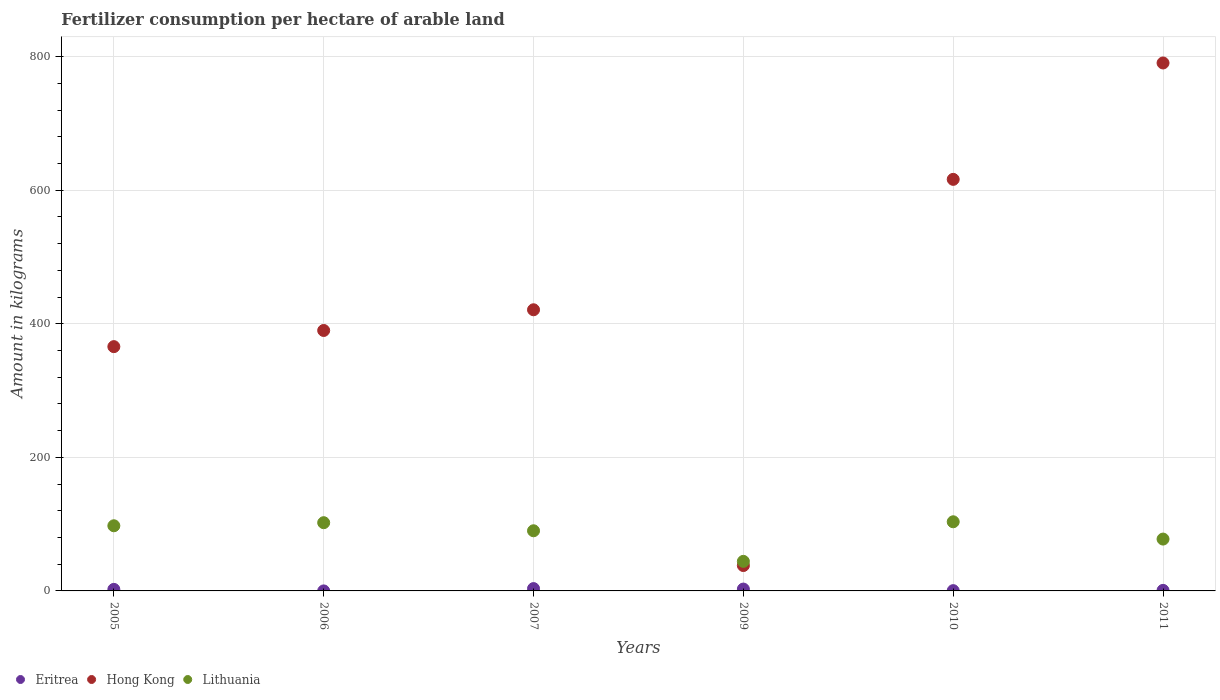How many different coloured dotlines are there?
Provide a short and direct response. 3. What is the amount of fertilizer consumption in Hong Kong in 2011?
Provide a succinct answer. 790.57. Across all years, what is the maximum amount of fertilizer consumption in Hong Kong?
Your answer should be compact. 790.57. Across all years, what is the minimum amount of fertilizer consumption in Eritrea?
Provide a short and direct response. 0.02. In which year was the amount of fertilizer consumption in Hong Kong maximum?
Offer a terse response. 2011. In which year was the amount of fertilizer consumption in Lithuania minimum?
Your answer should be very brief. 2009. What is the total amount of fertilizer consumption in Lithuania in the graph?
Keep it short and to the point. 515.22. What is the difference between the amount of fertilizer consumption in Lithuania in 2007 and that in 2010?
Offer a terse response. -13.47. What is the difference between the amount of fertilizer consumption in Lithuania in 2011 and the amount of fertilizer consumption in Eritrea in 2009?
Your response must be concise. 74.85. What is the average amount of fertilizer consumption in Hong Kong per year?
Your answer should be very brief. 436.94. In the year 2006, what is the difference between the amount of fertilizer consumption in Hong Kong and amount of fertilizer consumption in Lithuania?
Offer a terse response. 287.83. What is the ratio of the amount of fertilizer consumption in Lithuania in 2007 to that in 2009?
Your answer should be compact. 2.04. Is the amount of fertilizer consumption in Lithuania in 2009 less than that in 2011?
Provide a succinct answer. Yes. What is the difference between the highest and the second highest amount of fertilizer consumption in Hong Kong?
Your answer should be very brief. 174.29. What is the difference between the highest and the lowest amount of fertilizer consumption in Eritrea?
Your response must be concise. 3.47. Is the sum of the amount of fertilizer consumption in Eritrea in 2005 and 2010 greater than the maximum amount of fertilizer consumption in Lithuania across all years?
Ensure brevity in your answer.  No. Is the amount of fertilizer consumption in Hong Kong strictly greater than the amount of fertilizer consumption in Eritrea over the years?
Ensure brevity in your answer.  Yes. What is the difference between two consecutive major ticks on the Y-axis?
Your answer should be compact. 200. Does the graph contain any zero values?
Provide a short and direct response. No. Where does the legend appear in the graph?
Offer a very short reply. Bottom left. What is the title of the graph?
Your response must be concise. Fertilizer consumption per hectare of arable land. Does "Romania" appear as one of the legend labels in the graph?
Provide a short and direct response. No. What is the label or title of the X-axis?
Your answer should be very brief. Years. What is the label or title of the Y-axis?
Your response must be concise. Amount in kilograms. What is the Amount in kilograms of Eritrea in 2005?
Offer a very short reply. 2.32. What is the Amount in kilograms in Hong Kong in 2005?
Offer a very short reply. 365.8. What is the Amount in kilograms of Lithuania in 2005?
Offer a very short reply. 97.56. What is the Amount in kilograms of Eritrea in 2006?
Offer a terse response. 0.02. What is the Amount in kilograms in Hong Kong in 2006?
Your answer should be compact. 390. What is the Amount in kilograms of Lithuania in 2006?
Provide a succinct answer. 102.17. What is the Amount in kilograms in Eritrea in 2007?
Your answer should be compact. 3.49. What is the Amount in kilograms of Hong Kong in 2007?
Make the answer very short. 421. What is the Amount in kilograms in Lithuania in 2007?
Offer a terse response. 90.07. What is the Amount in kilograms in Eritrea in 2009?
Provide a succinct answer. 2.78. What is the Amount in kilograms of Hong Kong in 2009?
Keep it short and to the point. 38. What is the Amount in kilograms of Lithuania in 2009?
Keep it short and to the point. 44.26. What is the Amount in kilograms in Eritrea in 2010?
Your response must be concise. 0.42. What is the Amount in kilograms of Hong Kong in 2010?
Provide a short and direct response. 616.29. What is the Amount in kilograms of Lithuania in 2010?
Make the answer very short. 103.53. What is the Amount in kilograms in Eritrea in 2011?
Keep it short and to the point. 0.82. What is the Amount in kilograms of Hong Kong in 2011?
Offer a very short reply. 790.57. What is the Amount in kilograms in Lithuania in 2011?
Your answer should be compact. 77.63. Across all years, what is the maximum Amount in kilograms in Eritrea?
Your answer should be compact. 3.49. Across all years, what is the maximum Amount in kilograms of Hong Kong?
Your response must be concise. 790.57. Across all years, what is the maximum Amount in kilograms in Lithuania?
Give a very brief answer. 103.53. Across all years, what is the minimum Amount in kilograms of Eritrea?
Ensure brevity in your answer.  0.02. Across all years, what is the minimum Amount in kilograms of Lithuania?
Your answer should be very brief. 44.26. What is the total Amount in kilograms of Eritrea in the graph?
Your answer should be compact. 9.84. What is the total Amount in kilograms in Hong Kong in the graph?
Provide a short and direct response. 2621.66. What is the total Amount in kilograms of Lithuania in the graph?
Your answer should be compact. 515.22. What is the difference between the Amount in kilograms in Eritrea in 2005 and that in 2006?
Your answer should be compact. 2.3. What is the difference between the Amount in kilograms in Hong Kong in 2005 and that in 2006?
Offer a very short reply. -24.2. What is the difference between the Amount in kilograms in Lithuania in 2005 and that in 2006?
Provide a short and direct response. -4.6. What is the difference between the Amount in kilograms of Eritrea in 2005 and that in 2007?
Your answer should be very brief. -1.17. What is the difference between the Amount in kilograms of Hong Kong in 2005 and that in 2007?
Your answer should be very brief. -55.2. What is the difference between the Amount in kilograms in Lithuania in 2005 and that in 2007?
Give a very brief answer. 7.5. What is the difference between the Amount in kilograms in Eritrea in 2005 and that in 2009?
Your response must be concise. -0.47. What is the difference between the Amount in kilograms in Hong Kong in 2005 and that in 2009?
Offer a very short reply. 327.8. What is the difference between the Amount in kilograms of Lithuania in 2005 and that in 2009?
Provide a short and direct response. 53.31. What is the difference between the Amount in kilograms in Eritrea in 2005 and that in 2010?
Provide a short and direct response. 1.9. What is the difference between the Amount in kilograms of Hong Kong in 2005 and that in 2010?
Provide a succinct answer. -250.49. What is the difference between the Amount in kilograms in Lithuania in 2005 and that in 2010?
Your answer should be very brief. -5.97. What is the difference between the Amount in kilograms in Eritrea in 2005 and that in 2011?
Make the answer very short. 1.49. What is the difference between the Amount in kilograms in Hong Kong in 2005 and that in 2011?
Provide a short and direct response. -424.77. What is the difference between the Amount in kilograms of Lithuania in 2005 and that in 2011?
Your answer should be compact. 19.93. What is the difference between the Amount in kilograms of Eritrea in 2006 and that in 2007?
Ensure brevity in your answer.  -3.47. What is the difference between the Amount in kilograms of Hong Kong in 2006 and that in 2007?
Give a very brief answer. -31. What is the difference between the Amount in kilograms of Lithuania in 2006 and that in 2007?
Provide a short and direct response. 12.1. What is the difference between the Amount in kilograms of Eritrea in 2006 and that in 2009?
Your response must be concise. -2.77. What is the difference between the Amount in kilograms of Hong Kong in 2006 and that in 2009?
Your response must be concise. 352. What is the difference between the Amount in kilograms in Lithuania in 2006 and that in 2009?
Keep it short and to the point. 57.91. What is the difference between the Amount in kilograms of Eritrea in 2006 and that in 2010?
Ensure brevity in your answer.  -0.4. What is the difference between the Amount in kilograms in Hong Kong in 2006 and that in 2010?
Offer a very short reply. -226.29. What is the difference between the Amount in kilograms of Lithuania in 2006 and that in 2010?
Provide a succinct answer. -1.37. What is the difference between the Amount in kilograms in Eritrea in 2006 and that in 2011?
Give a very brief answer. -0.81. What is the difference between the Amount in kilograms of Hong Kong in 2006 and that in 2011?
Offer a terse response. -400.57. What is the difference between the Amount in kilograms in Lithuania in 2006 and that in 2011?
Ensure brevity in your answer.  24.54. What is the difference between the Amount in kilograms in Eritrea in 2007 and that in 2009?
Keep it short and to the point. 0.71. What is the difference between the Amount in kilograms in Hong Kong in 2007 and that in 2009?
Provide a short and direct response. 383. What is the difference between the Amount in kilograms in Lithuania in 2007 and that in 2009?
Your answer should be very brief. 45.81. What is the difference between the Amount in kilograms of Eritrea in 2007 and that in 2010?
Your response must be concise. 3.07. What is the difference between the Amount in kilograms of Hong Kong in 2007 and that in 2010?
Make the answer very short. -195.29. What is the difference between the Amount in kilograms of Lithuania in 2007 and that in 2010?
Make the answer very short. -13.47. What is the difference between the Amount in kilograms of Eritrea in 2007 and that in 2011?
Your response must be concise. 2.67. What is the difference between the Amount in kilograms in Hong Kong in 2007 and that in 2011?
Your response must be concise. -369.57. What is the difference between the Amount in kilograms in Lithuania in 2007 and that in 2011?
Your answer should be very brief. 12.43. What is the difference between the Amount in kilograms of Eritrea in 2009 and that in 2010?
Offer a very short reply. 2.37. What is the difference between the Amount in kilograms of Hong Kong in 2009 and that in 2010?
Your answer should be very brief. -578.29. What is the difference between the Amount in kilograms of Lithuania in 2009 and that in 2010?
Provide a succinct answer. -59.28. What is the difference between the Amount in kilograms in Eritrea in 2009 and that in 2011?
Provide a short and direct response. 1.96. What is the difference between the Amount in kilograms in Hong Kong in 2009 and that in 2011?
Your response must be concise. -752.57. What is the difference between the Amount in kilograms of Lithuania in 2009 and that in 2011?
Give a very brief answer. -33.38. What is the difference between the Amount in kilograms of Eritrea in 2010 and that in 2011?
Offer a terse response. -0.4. What is the difference between the Amount in kilograms in Hong Kong in 2010 and that in 2011?
Make the answer very short. -174.29. What is the difference between the Amount in kilograms in Lithuania in 2010 and that in 2011?
Your answer should be very brief. 25.9. What is the difference between the Amount in kilograms of Eritrea in 2005 and the Amount in kilograms of Hong Kong in 2006?
Your response must be concise. -387.68. What is the difference between the Amount in kilograms of Eritrea in 2005 and the Amount in kilograms of Lithuania in 2006?
Provide a succinct answer. -99.85. What is the difference between the Amount in kilograms of Hong Kong in 2005 and the Amount in kilograms of Lithuania in 2006?
Make the answer very short. 263.63. What is the difference between the Amount in kilograms of Eritrea in 2005 and the Amount in kilograms of Hong Kong in 2007?
Your answer should be very brief. -418.68. What is the difference between the Amount in kilograms in Eritrea in 2005 and the Amount in kilograms in Lithuania in 2007?
Provide a succinct answer. -87.75. What is the difference between the Amount in kilograms in Hong Kong in 2005 and the Amount in kilograms in Lithuania in 2007?
Give a very brief answer. 275.73. What is the difference between the Amount in kilograms in Eritrea in 2005 and the Amount in kilograms in Hong Kong in 2009?
Offer a terse response. -35.68. What is the difference between the Amount in kilograms of Eritrea in 2005 and the Amount in kilograms of Lithuania in 2009?
Give a very brief answer. -41.94. What is the difference between the Amount in kilograms in Hong Kong in 2005 and the Amount in kilograms in Lithuania in 2009?
Ensure brevity in your answer.  321.54. What is the difference between the Amount in kilograms of Eritrea in 2005 and the Amount in kilograms of Hong Kong in 2010?
Your response must be concise. -613.97. What is the difference between the Amount in kilograms in Eritrea in 2005 and the Amount in kilograms in Lithuania in 2010?
Your response must be concise. -101.22. What is the difference between the Amount in kilograms in Hong Kong in 2005 and the Amount in kilograms in Lithuania in 2010?
Offer a very short reply. 262.27. What is the difference between the Amount in kilograms of Eritrea in 2005 and the Amount in kilograms of Hong Kong in 2011?
Provide a succinct answer. -788.26. What is the difference between the Amount in kilograms in Eritrea in 2005 and the Amount in kilograms in Lithuania in 2011?
Your answer should be very brief. -75.32. What is the difference between the Amount in kilograms in Hong Kong in 2005 and the Amount in kilograms in Lithuania in 2011?
Provide a succinct answer. 288.17. What is the difference between the Amount in kilograms in Eritrea in 2006 and the Amount in kilograms in Hong Kong in 2007?
Offer a terse response. -420.98. What is the difference between the Amount in kilograms in Eritrea in 2006 and the Amount in kilograms in Lithuania in 2007?
Offer a terse response. -90.05. What is the difference between the Amount in kilograms of Hong Kong in 2006 and the Amount in kilograms of Lithuania in 2007?
Your response must be concise. 299.93. What is the difference between the Amount in kilograms of Eritrea in 2006 and the Amount in kilograms of Hong Kong in 2009?
Make the answer very short. -37.98. What is the difference between the Amount in kilograms in Eritrea in 2006 and the Amount in kilograms in Lithuania in 2009?
Offer a very short reply. -44.24. What is the difference between the Amount in kilograms of Hong Kong in 2006 and the Amount in kilograms of Lithuania in 2009?
Offer a very short reply. 345.74. What is the difference between the Amount in kilograms in Eritrea in 2006 and the Amount in kilograms in Hong Kong in 2010?
Keep it short and to the point. -616.27. What is the difference between the Amount in kilograms of Eritrea in 2006 and the Amount in kilograms of Lithuania in 2010?
Your response must be concise. -103.52. What is the difference between the Amount in kilograms of Hong Kong in 2006 and the Amount in kilograms of Lithuania in 2010?
Provide a short and direct response. 286.47. What is the difference between the Amount in kilograms in Eritrea in 2006 and the Amount in kilograms in Hong Kong in 2011?
Ensure brevity in your answer.  -790.55. What is the difference between the Amount in kilograms in Eritrea in 2006 and the Amount in kilograms in Lithuania in 2011?
Make the answer very short. -77.62. What is the difference between the Amount in kilograms of Hong Kong in 2006 and the Amount in kilograms of Lithuania in 2011?
Your answer should be compact. 312.37. What is the difference between the Amount in kilograms in Eritrea in 2007 and the Amount in kilograms in Hong Kong in 2009?
Give a very brief answer. -34.51. What is the difference between the Amount in kilograms in Eritrea in 2007 and the Amount in kilograms in Lithuania in 2009?
Provide a short and direct response. -40.77. What is the difference between the Amount in kilograms in Hong Kong in 2007 and the Amount in kilograms in Lithuania in 2009?
Provide a short and direct response. 376.74. What is the difference between the Amount in kilograms in Eritrea in 2007 and the Amount in kilograms in Hong Kong in 2010?
Offer a very short reply. -612.8. What is the difference between the Amount in kilograms of Eritrea in 2007 and the Amount in kilograms of Lithuania in 2010?
Offer a very short reply. -100.05. What is the difference between the Amount in kilograms of Hong Kong in 2007 and the Amount in kilograms of Lithuania in 2010?
Your answer should be very brief. 317.47. What is the difference between the Amount in kilograms of Eritrea in 2007 and the Amount in kilograms of Hong Kong in 2011?
Make the answer very short. -787.08. What is the difference between the Amount in kilograms in Eritrea in 2007 and the Amount in kilograms in Lithuania in 2011?
Offer a very short reply. -74.14. What is the difference between the Amount in kilograms in Hong Kong in 2007 and the Amount in kilograms in Lithuania in 2011?
Provide a short and direct response. 343.37. What is the difference between the Amount in kilograms in Eritrea in 2009 and the Amount in kilograms in Hong Kong in 2010?
Give a very brief answer. -613.5. What is the difference between the Amount in kilograms in Eritrea in 2009 and the Amount in kilograms in Lithuania in 2010?
Give a very brief answer. -100.75. What is the difference between the Amount in kilograms in Hong Kong in 2009 and the Amount in kilograms in Lithuania in 2010?
Make the answer very short. -65.53. What is the difference between the Amount in kilograms of Eritrea in 2009 and the Amount in kilograms of Hong Kong in 2011?
Your answer should be compact. -787.79. What is the difference between the Amount in kilograms of Eritrea in 2009 and the Amount in kilograms of Lithuania in 2011?
Keep it short and to the point. -74.85. What is the difference between the Amount in kilograms of Hong Kong in 2009 and the Amount in kilograms of Lithuania in 2011?
Provide a succinct answer. -39.63. What is the difference between the Amount in kilograms of Eritrea in 2010 and the Amount in kilograms of Hong Kong in 2011?
Keep it short and to the point. -790.15. What is the difference between the Amount in kilograms in Eritrea in 2010 and the Amount in kilograms in Lithuania in 2011?
Provide a short and direct response. -77.22. What is the difference between the Amount in kilograms of Hong Kong in 2010 and the Amount in kilograms of Lithuania in 2011?
Offer a terse response. 538.65. What is the average Amount in kilograms of Eritrea per year?
Keep it short and to the point. 1.64. What is the average Amount in kilograms of Hong Kong per year?
Offer a very short reply. 436.94. What is the average Amount in kilograms in Lithuania per year?
Your answer should be compact. 85.87. In the year 2005, what is the difference between the Amount in kilograms of Eritrea and Amount in kilograms of Hong Kong?
Ensure brevity in your answer.  -363.48. In the year 2005, what is the difference between the Amount in kilograms in Eritrea and Amount in kilograms in Lithuania?
Your answer should be very brief. -95.25. In the year 2005, what is the difference between the Amount in kilograms in Hong Kong and Amount in kilograms in Lithuania?
Your response must be concise. 268.24. In the year 2006, what is the difference between the Amount in kilograms in Eritrea and Amount in kilograms in Hong Kong?
Offer a terse response. -389.98. In the year 2006, what is the difference between the Amount in kilograms of Eritrea and Amount in kilograms of Lithuania?
Provide a short and direct response. -102.15. In the year 2006, what is the difference between the Amount in kilograms of Hong Kong and Amount in kilograms of Lithuania?
Provide a succinct answer. 287.83. In the year 2007, what is the difference between the Amount in kilograms of Eritrea and Amount in kilograms of Hong Kong?
Give a very brief answer. -417.51. In the year 2007, what is the difference between the Amount in kilograms in Eritrea and Amount in kilograms in Lithuania?
Offer a terse response. -86.58. In the year 2007, what is the difference between the Amount in kilograms of Hong Kong and Amount in kilograms of Lithuania?
Your answer should be compact. 330.93. In the year 2009, what is the difference between the Amount in kilograms of Eritrea and Amount in kilograms of Hong Kong?
Provide a succinct answer. -35.22. In the year 2009, what is the difference between the Amount in kilograms of Eritrea and Amount in kilograms of Lithuania?
Make the answer very short. -41.47. In the year 2009, what is the difference between the Amount in kilograms in Hong Kong and Amount in kilograms in Lithuania?
Provide a succinct answer. -6.26. In the year 2010, what is the difference between the Amount in kilograms in Eritrea and Amount in kilograms in Hong Kong?
Make the answer very short. -615.87. In the year 2010, what is the difference between the Amount in kilograms in Eritrea and Amount in kilograms in Lithuania?
Your response must be concise. -103.12. In the year 2010, what is the difference between the Amount in kilograms in Hong Kong and Amount in kilograms in Lithuania?
Your response must be concise. 512.75. In the year 2011, what is the difference between the Amount in kilograms of Eritrea and Amount in kilograms of Hong Kong?
Make the answer very short. -789.75. In the year 2011, what is the difference between the Amount in kilograms in Eritrea and Amount in kilograms in Lithuania?
Offer a terse response. -76.81. In the year 2011, what is the difference between the Amount in kilograms in Hong Kong and Amount in kilograms in Lithuania?
Offer a very short reply. 712.94. What is the ratio of the Amount in kilograms of Eritrea in 2005 to that in 2006?
Your response must be concise. 141.07. What is the ratio of the Amount in kilograms of Hong Kong in 2005 to that in 2006?
Make the answer very short. 0.94. What is the ratio of the Amount in kilograms in Lithuania in 2005 to that in 2006?
Make the answer very short. 0.95. What is the ratio of the Amount in kilograms in Eritrea in 2005 to that in 2007?
Your answer should be compact. 0.66. What is the ratio of the Amount in kilograms of Hong Kong in 2005 to that in 2007?
Give a very brief answer. 0.87. What is the ratio of the Amount in kilograms in Eritrea in 2005 to that in 2009?
Give a very brief answer. 0.83. What is the ratio of the Amount in kilograms in Hong Kong in 2005 to that in 2009?
Your answer should be compact. 9.63. What is the ratio of the Amount in kilograms of Lithuania in 2005 to that in 2009?
Offer a very short reply. 2.2. What is the ratio of the Amount in kilograms of Eritrea in 2005 to that in 2010?
Offer a very short reply. 5.55. What is the ratio of the Amount in kilograms in Hong Kong in 2005 to that in 2010?
Give a very brief answer. 0.59. What is the ratio of the Amount in kilograms in Lithuania in 2005 to that in 2010?
Give a very brief answer. 0.94. What is the ratio of the Amount in kilograms of Eritrea in 2005 to that in 2011?
Offer a terse response. 2.82. What is the ratio of the Amount in kilograms of Hong Kong in 2005 to that in 2011?
Offer a terse response. 0.46. What is the ratio of the Amount in kilograms in Lithuania in 2005 to that in 2011?
Your answer should be compact. 1.26. What is the ratio of the Amount in kilograms of Eritrea in 2006 to that in 2007?
Offer a very short reply. 0. What is the ratio of the Amount in kilograms of Hong Kong in 2006 to that in 2007?
Provide a short and direct response. 0.93. What is the ratio of the Amount in kilograms of Lithuania in 2006 to that in 2007?
Ensure brevity in your answer.  1.13. What is the ratio of the Amount in kilograms in Eritrea in 2006 to that in 2009?
Make the answer very short. 0.01. What is the ratio of the Amount in kilograms in Hong Kong in 2006 to that in 2009?
Keep it short and to the point. 10.26. What is the ratio of the Amount in kilograms of Lithuania in 2006 to that in 2009?
Ensure brevity in your answer.  2.31. What is the ratio of the Amount in kilograms in Eritrea in 2006 to that in 2010?
Provide a short and direct response. 0.04. What is the ratio of the Amount in kilograms of Hong Kong in 2006 to that in 2010?
Your response must be concise. 0.63. What is the ratio of the Amount in kilograms in Lithuania in 2006 to that in 2010?
Your response must be concise. 0.99. What is the ratio of the Amount in kilograms of Hong Kong in 2006 to that in 2011?
Offer a very short reply. 0.49. What is the ratio of the Amount in kilograms of Lithuania in 2006 to that in 2011?
Your answer should be compact. 1.32. What is the ratio of the Amount in kilograms of Eritrea in 2007 to that in 2009?
Your response must be concise. 1.25. What is the ratio of the Amount in kilograms of Hong Kong in 2007 to that in 2009?
Provide a succinct answer. 11.08. What is the ratio of the Amount in kilograms of Lithuania in 2007 to that in 2009?
Provide a succinct answer. 2.04. What is the ratio of the Amount in kilograms in Eritrea in 2007 to that in 2010?
Offer a very short reply. 8.36. What is the ratio of the Amount in kilograms of Hong Kong in 2007 to that in 2010?
Provide a short and direct response. 0.68. What is the ratio of the Amount in kilograms of Lithuania in 2007 to that in 2010?
Your response must be concise. 0.87. What is the ratio of the Amount in kilograms in Eritrea in 2007 to that in 2011?
Your answer should be compact. 4.25. What is the ratio of the Amount in kilograms of Hong Kong in 2007 to that in 2011?
Offer a terse response. 0.53. What is the ratio of the Amount in kilograms of Lithuania in 2007 to that in 2011?
Give a very brief answer. 1.16. What is the ratio of the Amount in kilograms of Eritrea in 2009 to that in 2010?
Provide a short and direct response. 6.67. What is the ratio of the Amount in kilograms of Hong Kong in 2009 to that in 2010?
Offer a terse response. 0.06. What is the ratio of the Amount in kilograms of Lithuania in 2009 to that in 2010?
Keep it short and to the point. 0.43. What is the ratio of the Amount in kilograms in Eritrea in 2009 to that in 2011?
Offer a very short reply. 3.39. What is the ratio of the Amount in kilograms in Hong Kong in 2009 to that in 2011?
Your answer should be very brief. 0.05. What is the ratio of the Amount in kilograms of Lithuania in 2009 to that in 2011?
Your response must be concise. 0.57. What is the ratio of the Amount in kilograms in Eritrea in 2010 to that in 2011?
Provide a short and direct response. 0.51. What is the ratio of the Amount in kilograms of Hong Kong in 2010 to that in 2011?
Provide a succinct answer. 0.78. What is the ratio of the Amount in kilograms of Lithuania in 2010 to that in 2011?
Your response must be concise. 1.33. What is the difference between the highest and the second highest Amount in kilograms of Eritrea?
Ensure brevity in your answer.  0.71. What is the difference between the highest and the second highest Amount in kilograms of Hong Kong?
Your response must be concise. 174.29. What is the difference between the highest and the second highest Amount in kilograms of Lithuania?
Offer a very short reply. 1.37. What is the difference between the highest and the lowest Amount in kilograms in Eritrea?
Offer a very short reply. 3.47. What is the difference between the highest and the lowest Amount in kilograms of Hong Kong?
Offer a very short reply. 752.57. What is the difference between the highest and the lowest Amount in kilograms in Lithuania?
Give a very brief answer. 59.28. 